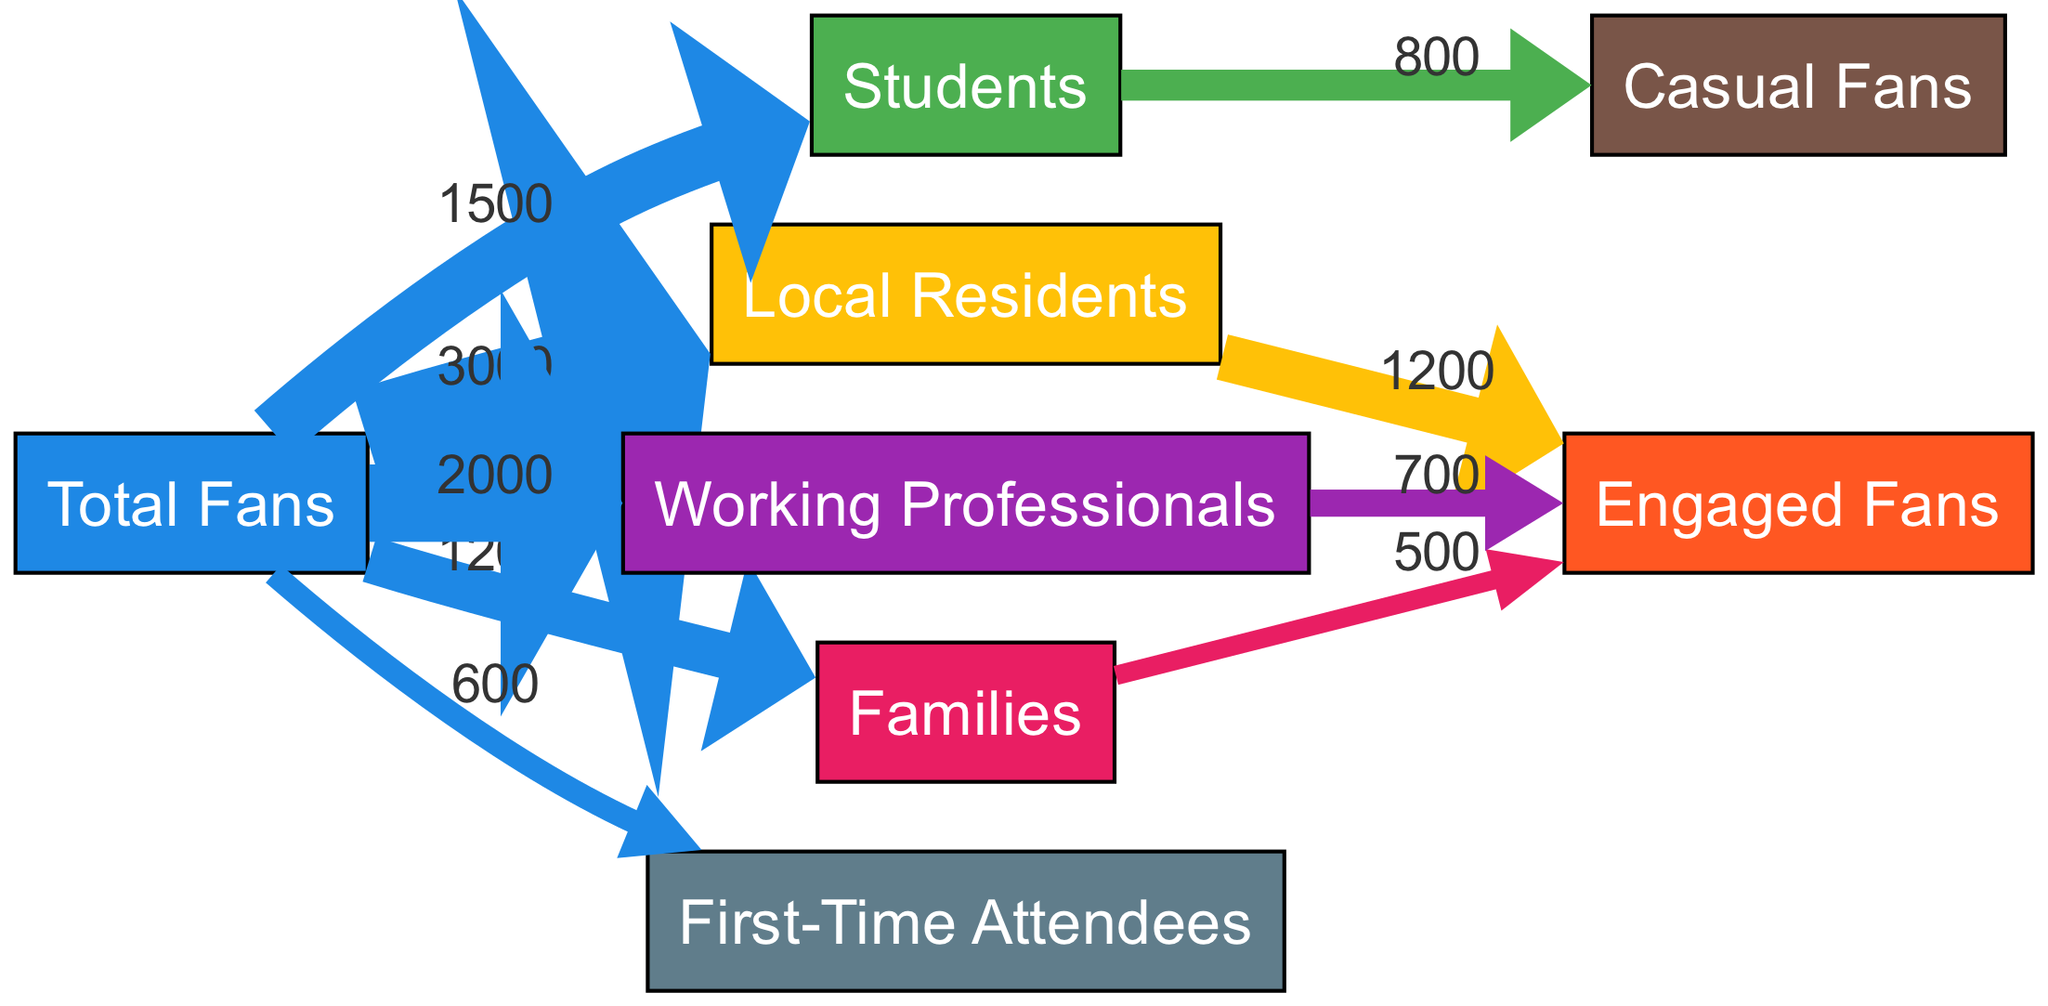What is the total number of fans? To find the total number of fans, we look at the "Total Fans" node in the diagram. It directly lists the number of fans as 6000.
Answer: 6000 How many local residents are fans? The "Local Residents" node shows that there are 3000 fans who are local residents.
Answer: 3000 What is the number of students who are engaged fans? There is no direct link from the "Students" node to the "Engaged Fans" node, indicating that none of the 1500 students are engaged fans.
Answer: 0 What percentage of families are engaged fans? We calculate the engaged fans from families. The "Families" node has 1200 fans, and out of these, 500 are engaged fans. The percentage is (500 / 1200) * 100 = 41.67%.
Answer: 41.67% How many first-time attendees are there? The "First-Time Attendees" link from the "Total Fans" node indicates that there are 600 first-time attendees.
Answer: 600 Which group has the highest number of engaged fans? We observe the links from each fan group to the "Engaged Fans" node: Local Residents (1200), Working Professionals (700), Families (500). Local Residents have the highest number at 1200.
Answer: Local Residents Which demographic has the most casual fans? The "Casual Fans" link shows that students contribute 800 to this category. Therefore, students have the most casual fans.
Answer: Students What is the total number of working professionals who are engaged fans? The "Working Professionals" node shows 2000 fans, with 700 categorized as engaged fans. Thus, there are 700 engaged working professionals.
Answer: 700 What percentage of total fans are first-time attendees? The total fans are 6000. The first-time attendees are 600, so the percentage is (600 / 6000) * 100 = 10%.
Answer: 10% 